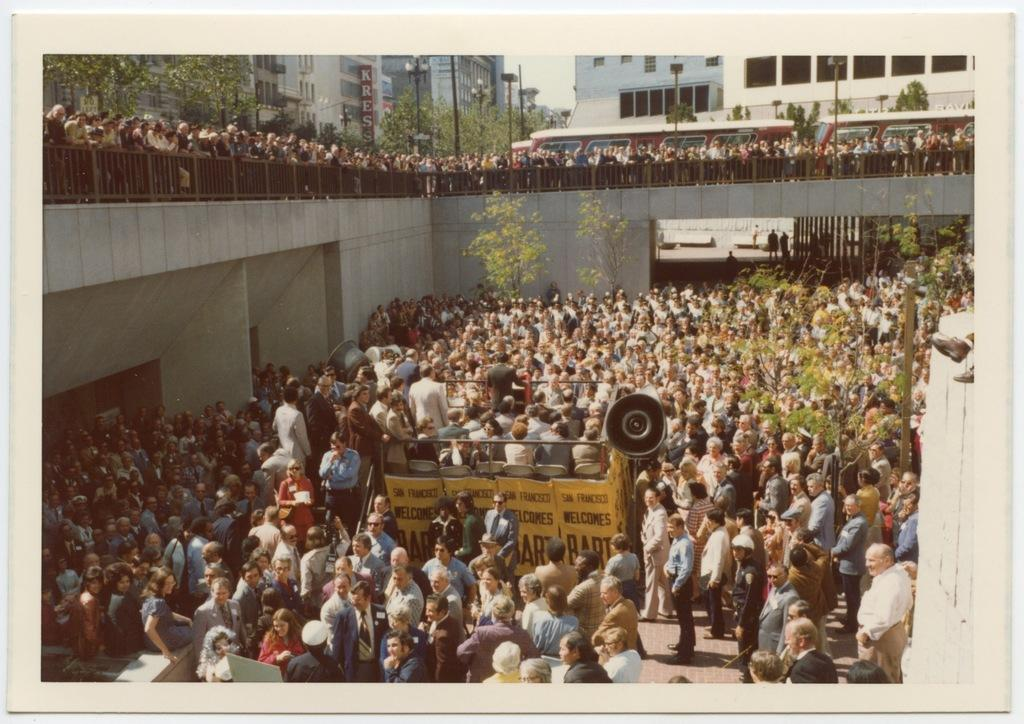How many people are in the image? There are many people in the image. What are some of the people in the image doing? Some people are standing near the rail at the top of the image. What can be seen in the background of the image? There are buildings in the background of the image. What is written on the buildings? There is text written on the buildings. What type of lamp is being used for digestion by the woman in the image? There is no woman or lamp present in the image, and therefore no such activity can be observed. 